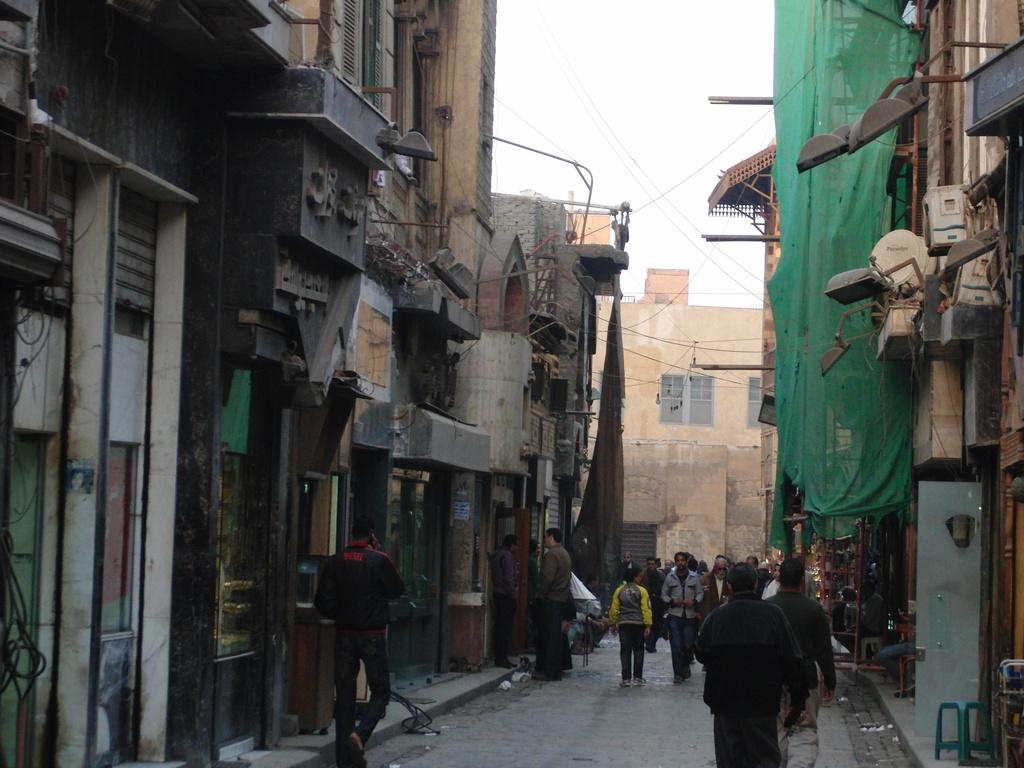What are the people in the image doing? There is a group of people walking in the street. What can be seen in the background of the image? There are lights, doors, chairs, buildings, pipes, and the sky visible in the background. How many men are part of the flock in the image? There is no flock or men present in the image; it features a group of people walking in the street. What type of industry can be seen in the background of the image? There is no industry visible in the background of the image. 